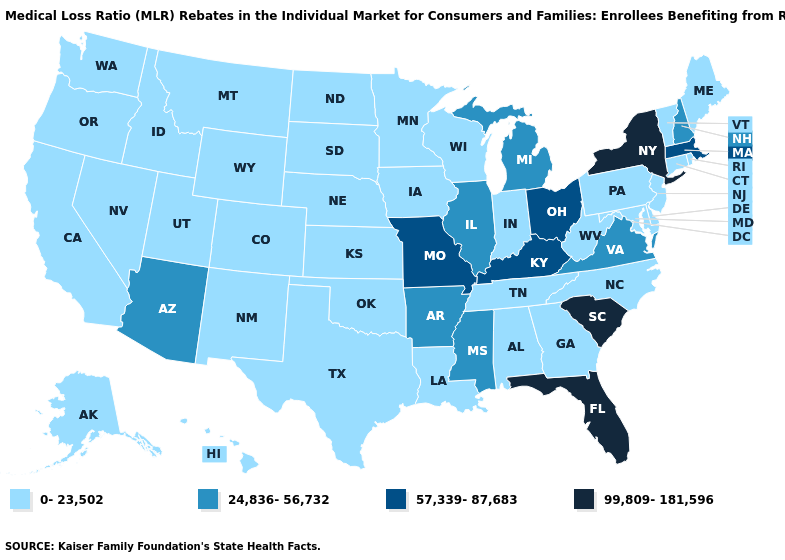What is the value of Idaho?
Write a very short answer. 0-23,502. Does Arkansas have the lowest value in the USA?
Quick response, please. No. What is the value of Connecticut?
Be succinct. 0-23,502. Name the states that have a value in the range 57,339-87,683?
Answer briefly. Kentucky, Massachusetts, Missouri, Ohio. What is the highest value in states that border Illinois?
Short answer required. 57,339-87,683. Does Utah have a higher value than Idaho?
Concise answer only. No. What is the highest value in the USA?
Be succinct. 99,809-181,596. Name the states that have a value in the range 24,836-56,732?
Keep it brief. Arizona, Arkansas, Illinois, Michigan, Mississippi, New Hampshire, Virginia. Name the states that have a value in the range 0-23,502?
Answer briefly. Alabama, Alaska, California, Colorado, Connecticut, Delaware, Georgia, Hawaii, Idaho, Indiana, Iowa, Kansas, Louisiana, Maine, Maryland, Minnesota, Montana, Nebraska, Nevada, New Jersey, New Mexico, North Carolina, North Dakota, Oklahoma, Oregon, Pennsylvania, Rhode Island, South Dakota, Tennessee, Texas, Utah, Vermont, Washington, West Virginia, Wisconsin, Wyoming. Does California have the highest value in the USA?
Be succinct. No. What is the value of Rhode Island?
Quick response, please. 0-23,502. What is the lowest value in the West?
Concise answer only. 0-23,502. Which states have the lowest value in the MidWest?
Be succinct. Indiana, Iowa, Kansas, Minnesota, Nebraska, North Dakota, South Dakota, Wisconsin. Does North Dakota have the lowest value in the USA?
Write a very short answer. Yes. Does Colorado have the same value as Idaho?
Keep it brief. Yes. 